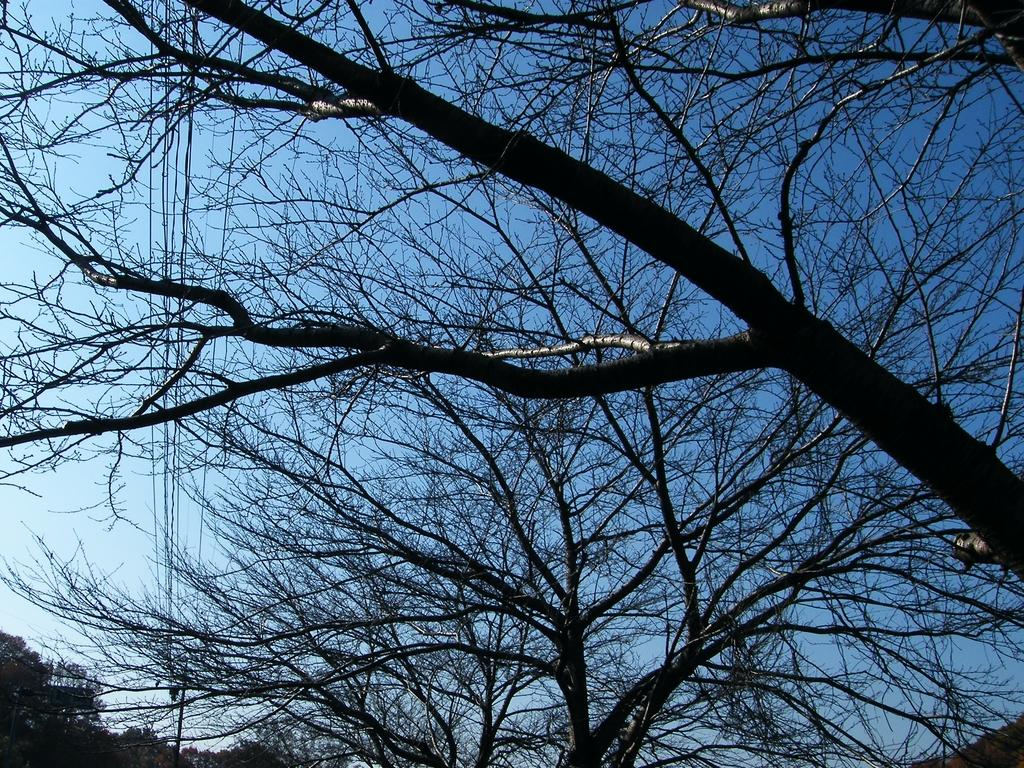What type of natural elements can be seen in the image? There are trees in the image. What man-made structures are present in the image? There are wires in the image. What can be seen in the distance in the image? The sky is visible in the background of the image. How many waves can be seen crashing on the shore in the image? There are no waves present in the image; it features trees and wires. What type of attention is the image trying to draw from the viewer? The image is not trying to draw any specific type of attention from the viewer; it simply presents the trees, wires, and sky. 